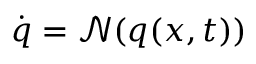Convert formula to latex. <formula><loc_0><loc_0><loc_500><loc_500>\dot { q } = \mathcal { N } ( q ( x , t ) )</formula> 